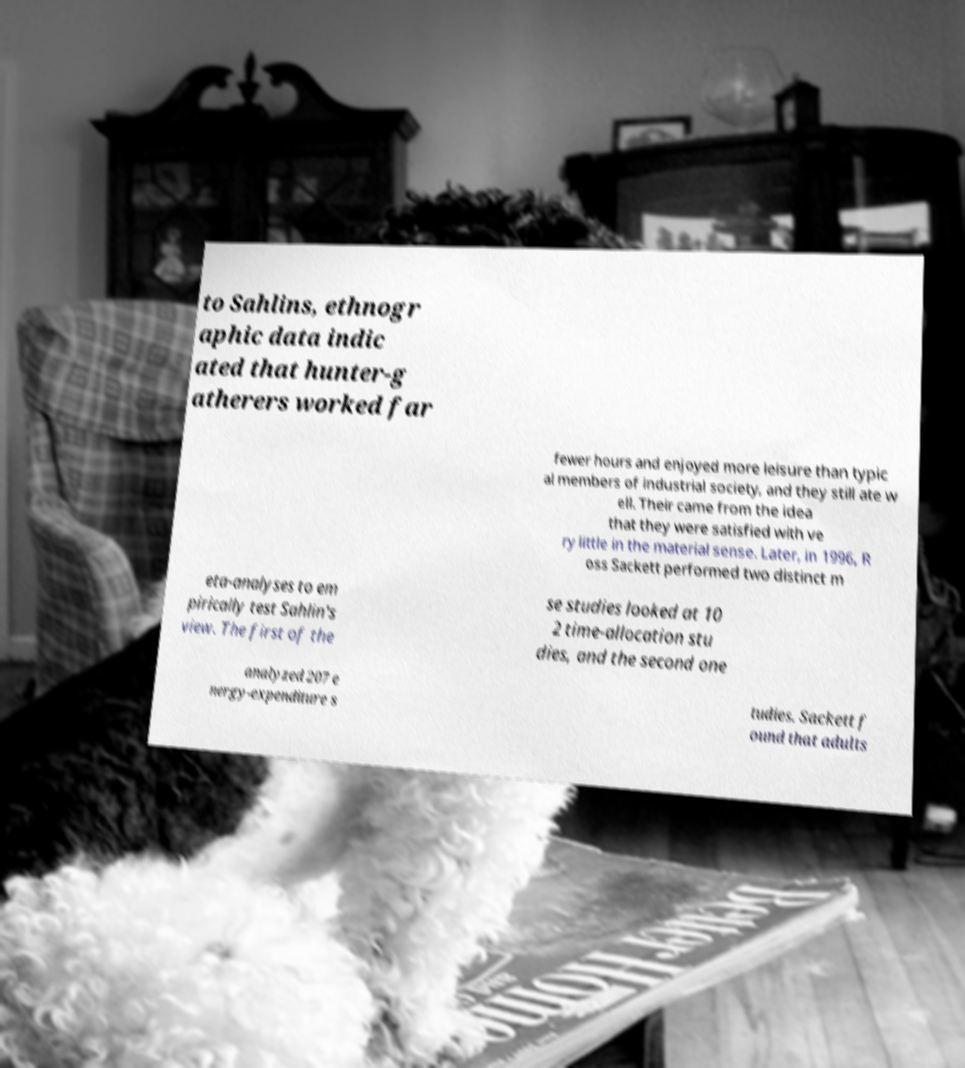Could you assist in decoding the text presented in this image and type it out clearly? to Sahlins, ethnogr aphic data indic ated that hunter-g atherers worked far fewer hours and enjoyed more leisure than typic al members of industrial society, and they still ate w ell. Their came from the idea that they were satisfied with ve ry little in the material sense. Later, in 1996, R oss Sackett performed two distinct m eta-analyses to em pirically test Sahlin's view. The first of the se studies looked at 10 2 time-allocation stu dies, and the second one analyzed 207 e nergy-expenditure s tudies. Sackett f ound that adults 